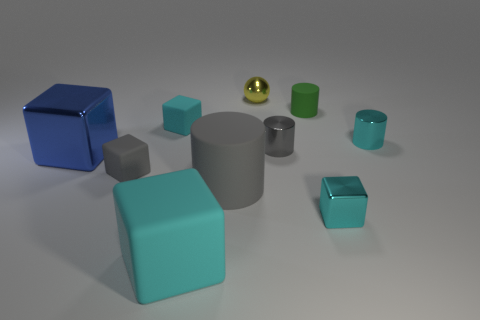Subtract all cyan spheres. How many cyan blocks are left? 3 Subtract all blue blocks. How many blocks are left? 4 Subtract all gray cubes. How many cubes are left? 4 Subtract 1 cylinders. How many cylinders are left? 3 Subtract all green cubes. Subtract all purple spheres. How many cubes are left? 5 Subtract all balls. How many objects are left? 9 Add 6 small cyan rubber cubes. How many small cyan rubber cubes exist? 7 Subtract 0 red spheres. How many objects are left? 10 Subtract all small metal cylinders. Subtract all small purple shiny objects. How many objects are left? 8 Add 9 large gray cylinders. How many large gray cylinders are left? 10 